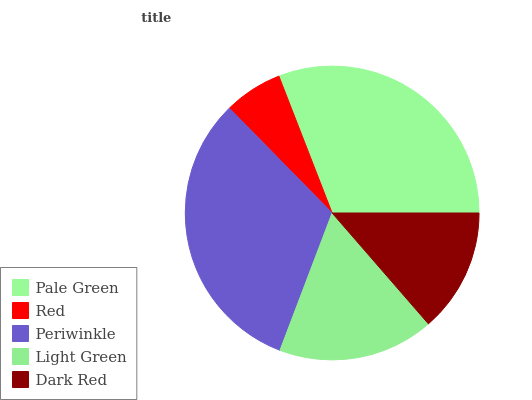Is Red the minimum?
Answer yes or no. Yes. Is Periwinkle the maximum?
Answer yes or no. Yes. Is Periwinkle the minimum?
Answer yes or no. No. Is Red the maximum?
Answer yes or no. No. Is Periwinkle greater than Red?
Answer yes or no. Yes. Is Red less than Periwinkle?
Answer yes or no. Yes. Is Red greater than Periwinkle?
Answer yes or no. No. Is Periwinkle less than Red?
Answer yes or no. No. Is Light Green the high median?
Answer yes or no. Yes. Is Light Green the low median?
Answer yes or no. Yes. Is Red the high median?
Answer yes or no. No. Is Red the low median?
Answer yes or no. No. 